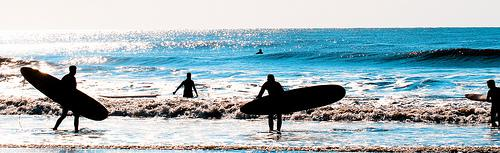Question: what is the color of the water?
Choices:
A. Green.
B. Blue.
C. Clear.
D. Blue-gree.
Answer with the letter. Answer: B Question: who is holding the surfboards?
Choices:
A. Women.
B. Kids.
C. Men.
D. A family.
Answer with the letter. Answer: C Question: what are the men holding?
Choices:
A. Frisbees.
B. Balls.
C. Surfboards.
D. A dog.
Answer with the letter. Answer: C Question: what time of the day it is?
Choices:
A. Noon.
B. One.
C. Two.
D. Three.
Answer with the letter. Answer: A Question: why the men holding the surfboards?
Choices:
A. To get to the water.
B. To surf.
C. For fun.
D. For exercise.
Answer with the letter. Answer: B 